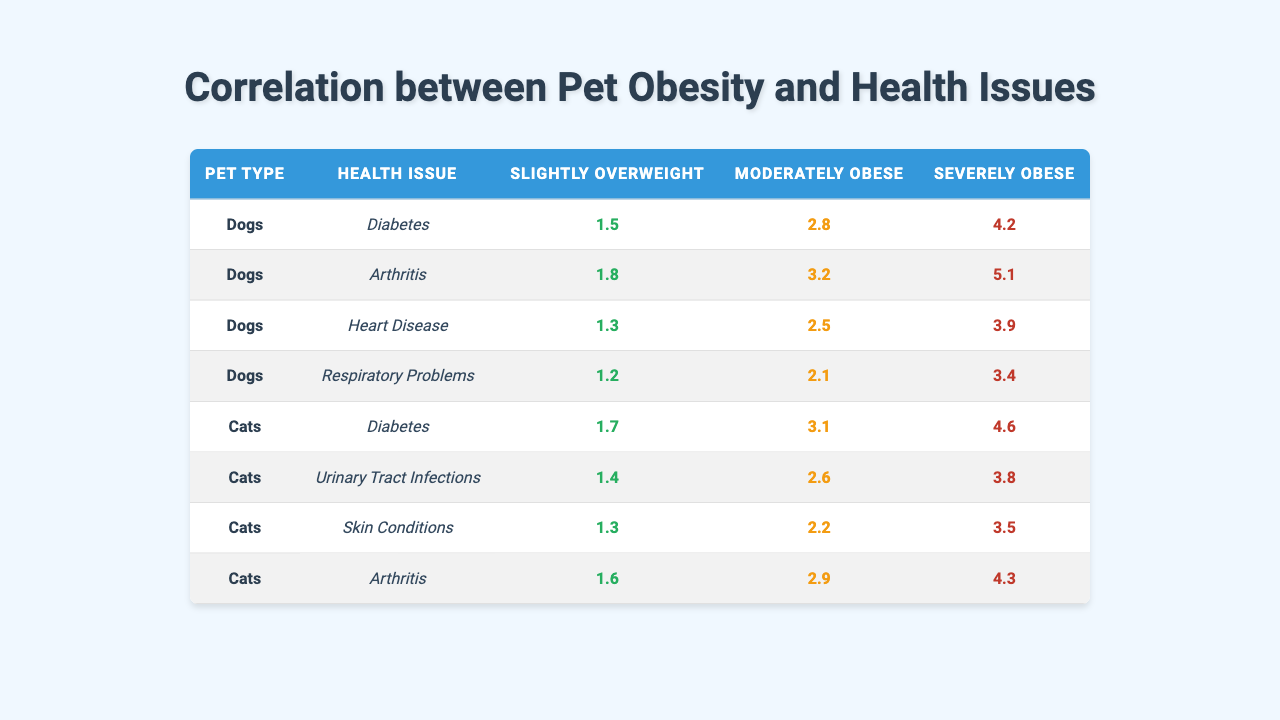What is the correlation value for dogs with diabetes who are moderately obese? The table shows a correlation value of 2.8 for dogs with diabetes in the moderately obese category.
Answer: 2.8 What health issue has the highest correlation value for severely obese dogs? Looking at the table, arthritis has the highest correlation value of 5.1 for severely obese dogs.
Answer: Arthritis Is the correlation for slightly overweight cats with urinary tract infections higher than that for slightly overweight dogs with heart disease? The correlation for slightly overweight cats with urinary tract infections is 1.4, while for slightly overweight dogs with heart disease it is 1.3. Therefore, it is higher.
Answer: Yes What is the difference in correlation values between moderately obese cats with diabetes and severely obese cats with skin conditions? The correlation for moderately obese cats with diabetes is 3.1 and for severely obese cats with skin conditions is 3.5. The difference is calculated as 3.5 - 3.1 = 0.4.
Answer: 0.4 Which health issue has the lowest correlation value for slightly overweight dogs? The table indicates that respiratory problems have the lowest correlation value of 1.2 for slightly overweight dogs.
Answer: Respiratory Problems What is the average correlation value for severely obese dogs across all health issues listed? The values for severely obese dogs across all health issues are 4.2 (diabetes), 5.1 (arthritis), 3.9 (heart disease), and 3.4 (respiratory problems). The total sum is 4.2 + 5.1 + 3.9 + 3.4 = 16.6, and there are 4 health issues, so the average is 16.6/4 = 4.15.
Answer: 4.15 Do severely obese cats have a higher correlation value for skin conditions compared to slightly overweight dogs with diabetes? The correlation for severely obese cats with skin conditions is 3.5, while for slightly overweight dogs with diabetes it is 1.5. Thus, severely obese cats have a higher value.
Answer: Yes What is the highest correlation value for slightly overweight pets across both dogs and cats? The highest correlation value for slightly overweight pets is 1.8, which corresponds to slightly overweight dogs with arthritis.
Answer: 1.8 How many health issues for dogs have a correlation value of over 4 when severely obese? The table shows that only one health issue (arthritis) has a correlation value of 5.1, which is over 4 for severely obese dogs.
Answer: 1 Which has a greater correlation value, moderately obese cats with urinary tract infections or severely obese dogs with heart disease? The correlation value for moderately obese cats with urinary tract infections is 2.6, and for severely obese dogs with heart disease it is 3.9. The value for severely obese dogs with heart disease is greater.
Answer: Severely obese dogs with heart disease 